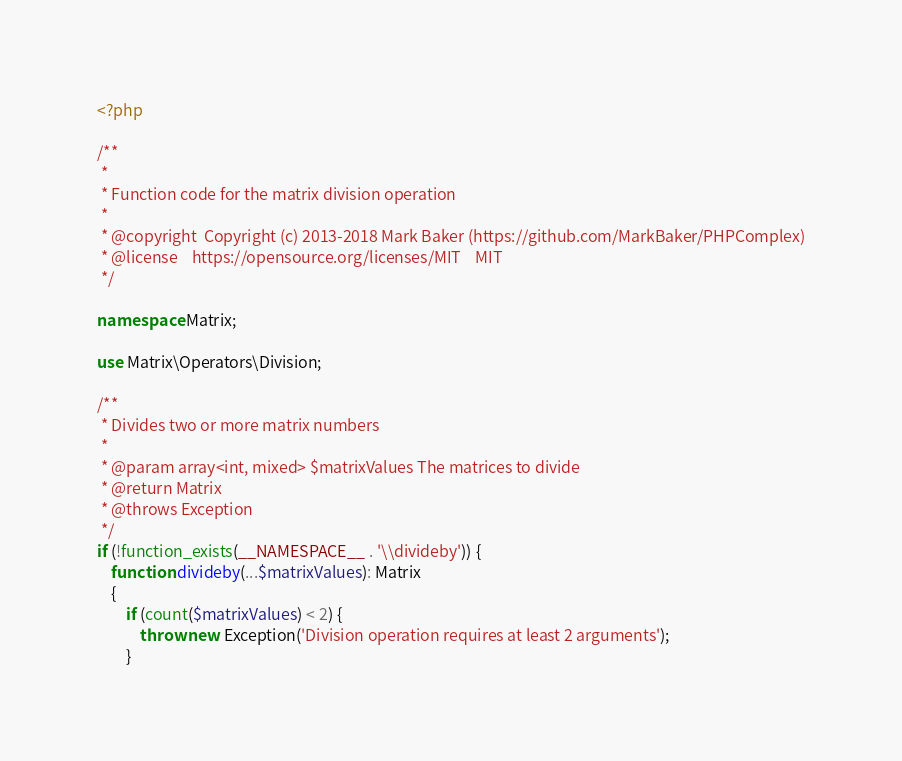<code> <loc_0><loc_0><loc_500><loc_500><_PHP_><?php

/**
 *
 * Function code for the matrix division operation
 *
 * @copyright  Copyright (c) 2013-2018 Mark Baker (https://github.com/MarkBaker/PHPComplex)
 * @license    https://opensource.org/licenses/MIT    MIT
 */

namespace Matrix;

use Matrix\Operators\Division;

/**
 * Divides two or more matrix numbers
 *
 * @param array<int, mixed> $matrixValues The matrices to divide
 * @return Matrix
 * @throws Exception
 */
if (!function_exists(__NAMESPACE__ . '\\divideby')) {
    function divideby(...$matrixValues): Matrix
    {
        if (count($matrixValues) < 2) {
            throw new Exception('Division operation requires at least 2 arguments');
        }
</code> 